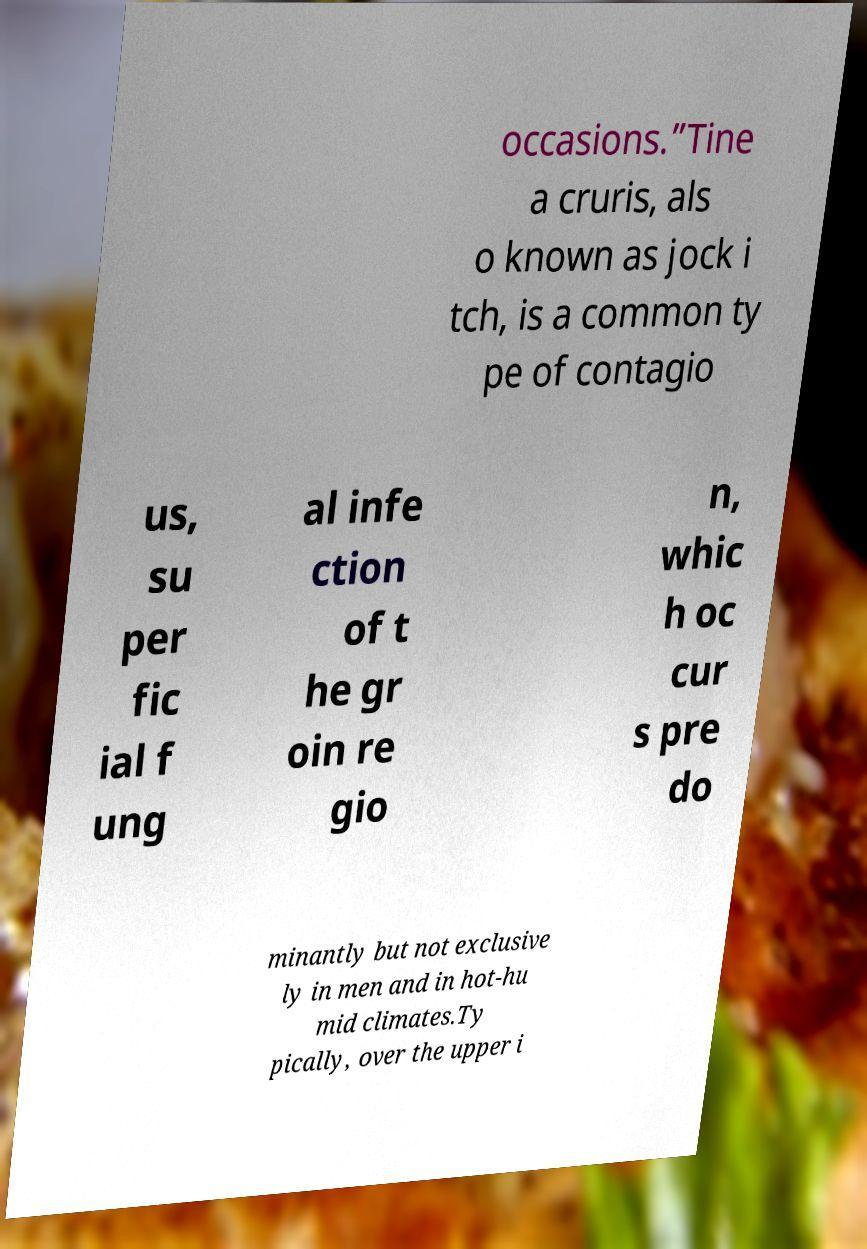Could you extract and type out the text from this image? occasions.”Tine a cruris, als o known as jock i tch, is a common ty pe of contagio us, su per fic ial f ung al infe ction of t he gr oin re gio n, whic h oc cur s pre do minantly but not exclusive ly in men and in hot-hu mid climates.Ty pically, over the upper i 